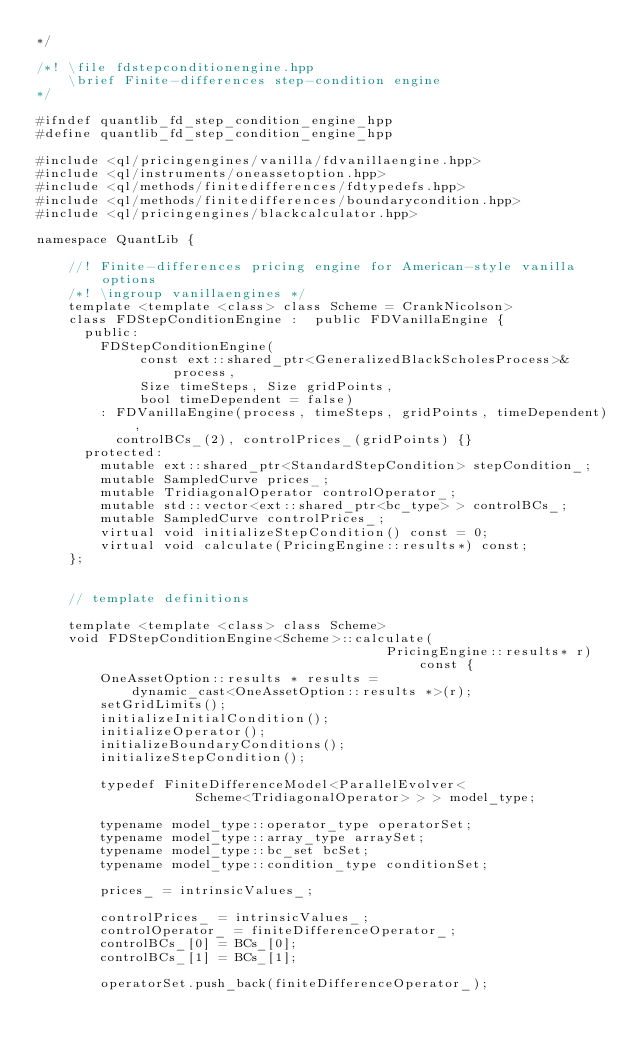Convert code to text. <code><loc_0><loc_0><loc_500><loc_500><_C++_>*/

/*! \file fdstepconditionengine.hpp
    \brief Finite-differences step-condition engine
*/

#ifndef quantlib_fd_step_condition_engine_hpp
#define quantlib_fd_step_condition_engine_hpp

#include <ql/pricingengines/vanilla/fdvanillaengine.hpp>
#include <ql/instruments/oneassetoption.hpp>
#include <ql/methods/finitedifferences/fdtypedefs.hpp>
#include <ql/methods/finitedifferences/boundarycondition.hpp>
#include <ql/pricingengines/blackcalculator.hpp>

namespace QuantLib {

    //! Finite-differences pricing engine for American-style vanilla options
    /*! \ingroup vanillaengines */
    template <template <class> class Scheme = CrankNicolson>
    class FDStepConditionEngine :  public FDVanillaEngine {
      public:
        FDStepConditionEngine(
             const ext::shared_ptr<GeneralizedBlackScholesProcess>& process,
             Size timeSteps, Size gridPoints,
             bool timeDependent = false)
        : FDVanillaEngine(process, timeSteps, gridPoints, timeDependent),
          controlBCs_(2), controlPrices_(gridPoints) {}
      protected:
        mutable ext::shared_ptr<StandardStepCondition> stepCondition_;
        mutable SampledCurve prices_;
        mutable TridiagonalOperator controlOperator_;
        mutable std::vector<ext::shared_ptr<bc_type> > controlBCs_;
        mutable SampledCurve controlPrices_;
        virtual void initializeStepCondition() const = 0;
        virtual void calculate(PricingEngine::results*) const;
    };


    // template definitions

    template <template <class> class Scheme>
    void FDStepConditionEngine<Scheme>::calculate(
                                            PricingEngine::results* r) const {
        OneAssetOption::results * results =
            dynamic_cast<OneAssetOption::results *>(r);
        setGridLimits();
        initializeInitialCondition();
        initializeOperator();
        initializeBoundaryConditions();
        initializeStepCondition();

        typedef FiniteDifferenceModel<ParallelEvolver<
                    Scheme<TridiagonalOperator> > > model_type;

        typename model_type::operator_type operatorSet;
        typename model_type::array_type arraySet;
        typename model_type::bc_set bcSet;
        typename model_type::condition_type conditionSet;

        prices_ = intrinsicValues_;

        controlPrices_ = intrinsicValues_;
        controlOperator_ = finiteDifferenceOperator_;
        controlBCs_[0] = BCs_[0];
        controlBCs_[1] = BCs_[1];

        operatorSet.push_back(finiteDifferenceOperator_);</code> 